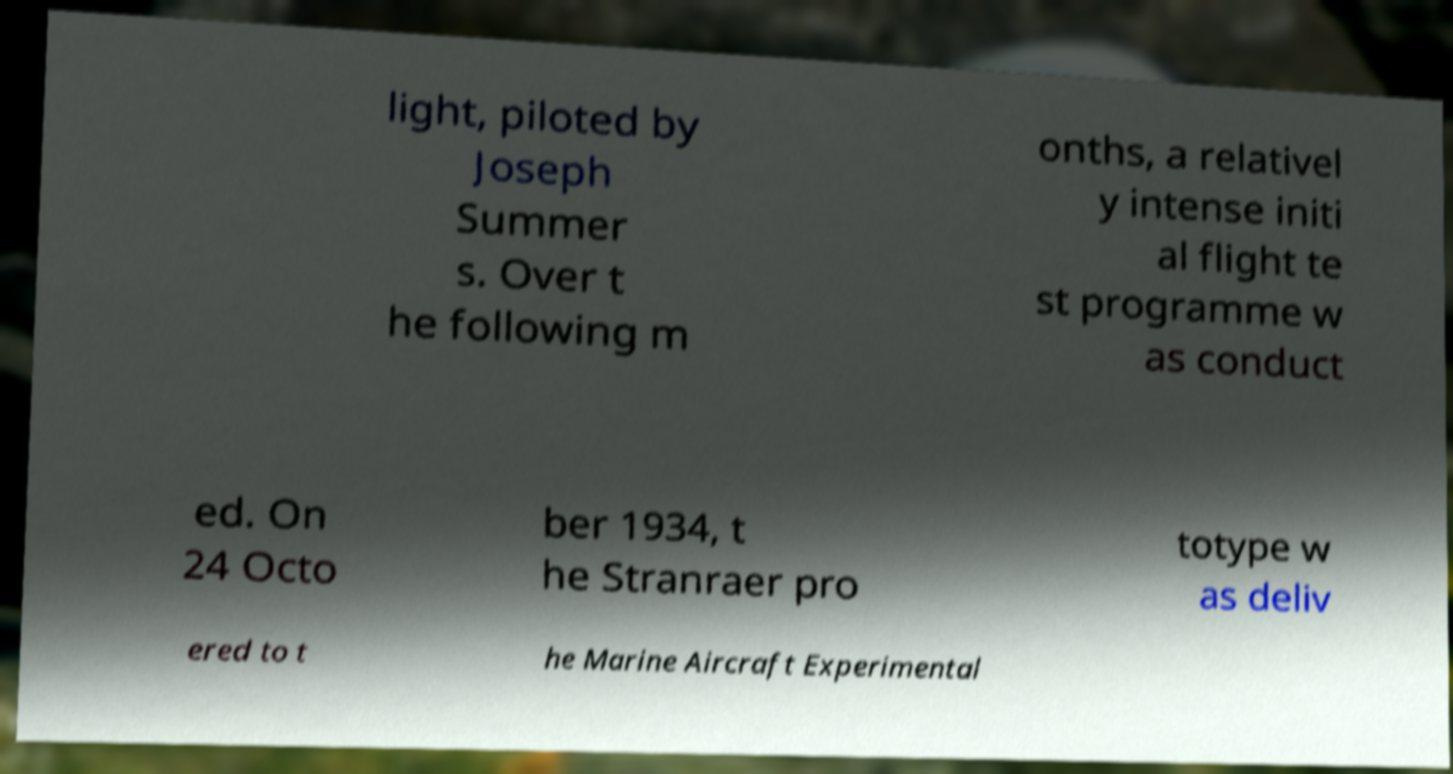I need the written content from this picture converted into text. Can you do that? light, piloted by Joseph Summer s. Over t he following m onths, a relativel y intense initi al flight te st programme w as conduct ed. On 24 Octo ber 1934, t he Stranraer pro totype w as deliv ered to t he Marine Aircraft Experimental 